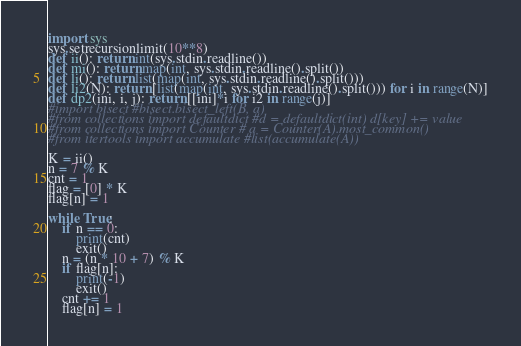<code> <loc_0><loc_0><loc_500><loc_500><_Python_>import sys
sys.setrecursionlimit(10**8)
def ii(): return int(sys.stdin.readline())
def mi(): return map(int, sys.stdin.readline().split())
def li(): return list(map(int, sys.stdin.readline().split()))
def li2(N): return [list(map(int, sys.stdin.readline().split())) for i in range(N)]
def dp2(ini, i, j): return [[ini]*i for i2 in range(j)]
#import bisect #bisect.bisect_left(B, a)
#from collections import defaultdict #d = defaultdict(int) d[key] += value
#from collections import Counter # a = Counter(A).most_common()
#from itertools import accumulate #list(accumulate(A))

K = ii()
n = 7 % K
cnt = 1
flag = [0] * K
flag[n] = 1

while True:
    if n == 0:
        print(cnt)
        exit()
    n = (n * 10 + 7) % K
    if flag[n]:
        print(-1)
        exit()
    cnt += 1
    flag[n] = 1</code> 